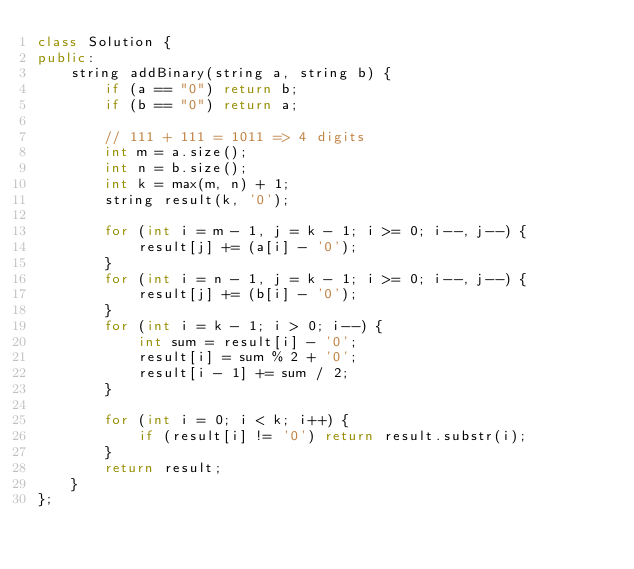<code> <loc_0><loc_0><loc_500><loc_500><_C++_>class Solution {
public:
    string addBinary(string a, string b) {
        if (a == "0") return b;
        if (b == "0") return a;

        // 111 + 111 = 1011 => 4 digits
        int m = a.size();
        int n = b.size();
        int k = max(m, n) + 1;
        string result(k, '0');

        for (int i = m - 1, j = k - 1; i >= 0; i--, j--) {
            result[j] += (a[i] - '0');
        }
        for (int i = n - 1, j = k - 1; i >= 0; i--, j--) {
            result[j] += (b[i] - '0');
        }
        for (int i = k - 1; i > 0; i--) {
            int sum = result[i] - '0';
            result[i] = sum % 2 + '0';
            result[i - 1] += sum / 2;
        }

        for (int i = 0; i < k; i++) {
            if (result[i] != '0') return result.substr(i);
        }
        return result;
    }
};
</code> 